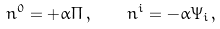Convert formula to latex. <formula><loc_0><loc_0><loc_500><loc_500>n ^ { 0 } = + \alpha \Pi \, , \quad n ^ { i } = - \alpha \Psi _ { i } \, ,</formula> 